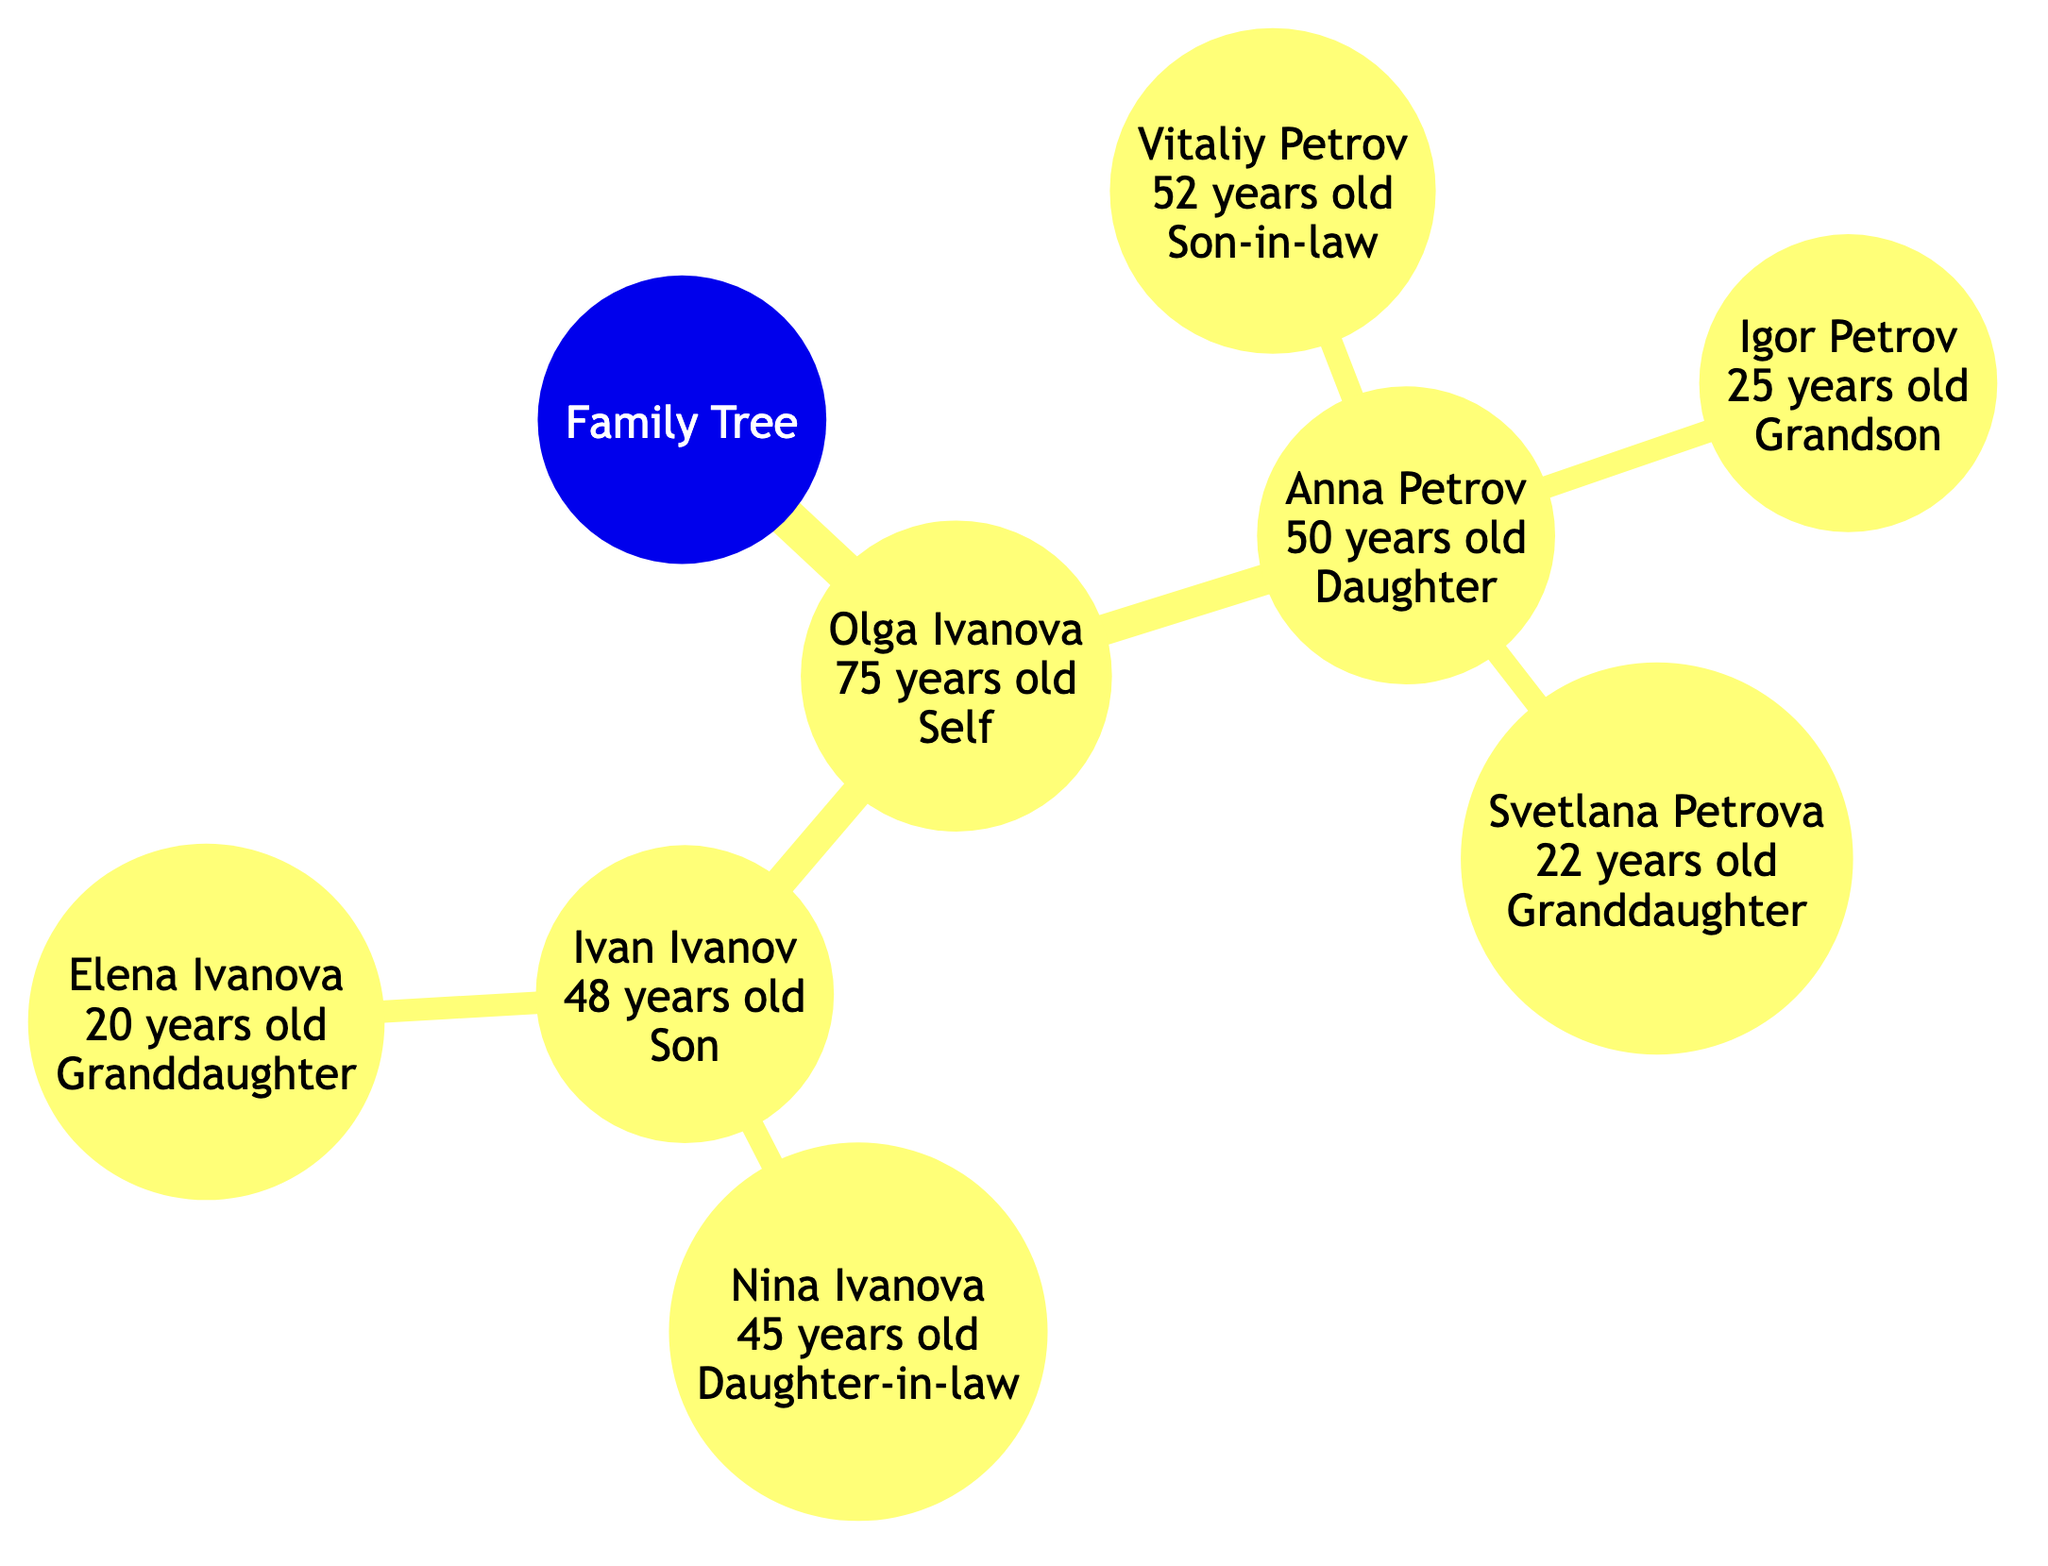What is the age of Olga Ivanova? According to the diagram, Olga Ivanova is labeled as 75 years old.
Answer: 75 What is the relationship of Vitaliy Petrov to Anna Petrov? The diagram indicates that Vitaliy Petrov is the spouse of Anna Petrov, meaning he is her son-in-law.
Answer: Son-in-law How many grandchildren does Olga Ivanova have? From the diagram, Olga Ivanova has three grandchildren: Igor Petrov, Svetlana Petrova, and Elena Ivanova. Thus, the total number is three.
Answer: 3 What is the relationship of Elena Ivanova to Ivan Ivanov? The diagram shows that Elena Ivanova is the child of Ivan Ivanov, making her his granddaughter.
Answer: Granddaughter What is the age of Nina Ivanova? The diagram shows that Nina Ivanova is labeled as 45 years old.
Answer: 45 Who is the daughter of Olga Ivanova? Based on the diagram, the daughter of Olga Ivanova is Anna Petrov.
Answer: Anna Petrov How is Svetlana Petrova related to Olga Ivanova? The diagram indicates that Svetlana Petrova is the daughter of Anna Petrov, who is Olga Ivanova's daughter, making Svetlana Petrova her granddaughter.
Answer: Granddaughter What is the relationship of Igor Petrov to Olga Ivanova? Igor Petrov is the child of Anna Petrov, who is the daughter of Olga Ivanova, making Igor Petrov her grandson.
Answer: Grandson What is the total number of direct children of Olga Ivanova? The diagram indicates that Olga Ivanova has two children: Anna Petrov and Ivan Ivanov. Thus, the total number is two.
Answer: 2 